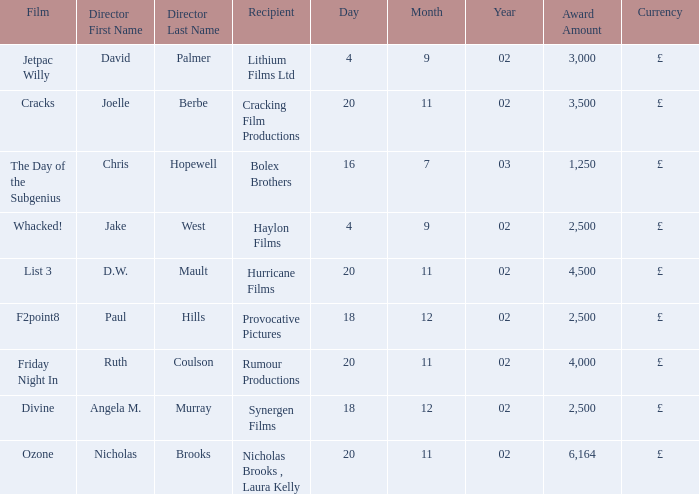What award did the film Ozone win? £6,164. Can you give me this table as a dict? {'header': ['Film', 'Director First Name', 'Director Last Name', 'Recipient', 'Day', 'Month', 'Year', 'Award Amount', 'Currency'], 'rows': [['Jetpac Willy', 'David', 'Palmer', 'Lithium Films Ltd', '4', '9', '02', '3,000', '£'], ['Cracks', 'Joelle', 'Berbe', 'Cracking Film Productions', '20', '11', '02', '3,500', '£'], ['The Day of the Subgenius', 'Chris', 'Hopewell', 'Bolex Brothers', '16', '7', '03', '1,250', '£'], ['Whacked!', 'Jake', 'West', 'Haylon Films', '4', '9', '02', '2,500', '£'], ['List 3', 'D.W.', 'Mault', 'Hurricane Films', '20', '11', '02', '4,500', '£'], ['F2point8', 'Paul', 'Hills', 'Provocative Pictures', '18', '12', '02', '2,500', '£'], ['Friday Night In', 'Ruth', 'Coulson', 'Rumour Productions', '20', '11', '02', '4,000', '£'], ['Divine', 'Angela M.', 'Murray', 'Synergen Films', '18', '12', '02', '2,500', '£'], ['Ozone', 'Nicholas', 'Brooks', 'Nicholas Brooks , Laura Kelly', '20', '11', '02', '6,164', '£']]} 